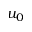<formula> <loc_0><loc_0><loc_500><loc_500>u _ { 0 }</formula> 